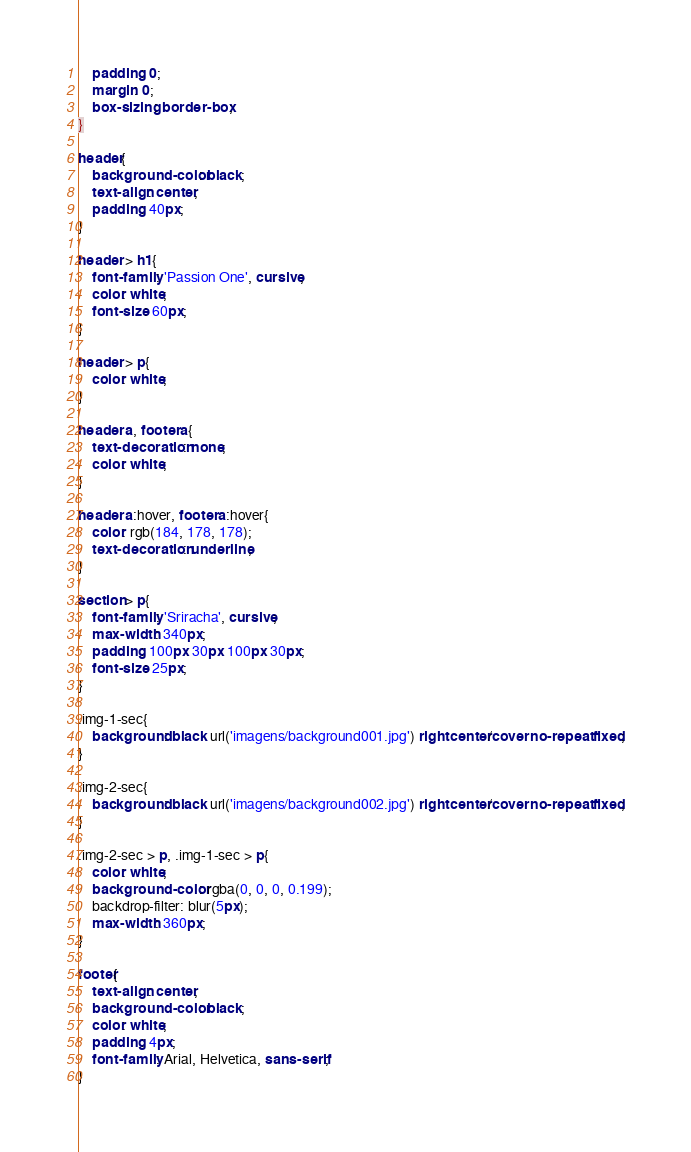Convert code to text. <code><loc_0><loc_0><loc_500><loc_500><_CSS_>    padding: 0;
    margin: 0;
    box-sizing: border-box;
}

header{
    background-color: black;
    text-align: center;
    padding: 40px;
}

header > h1{
    font-family: 'Passion One', cursive;
    color: white;
    font-size: 60px;
}

header > p{
    color: white;
}

header a, footer a{
    text-decoration: none;
    color: white;
}

header a:hover, footer a:hover{
    color: rgb(184, 178, 178);
    text-decoration: underline;
}

section > p{
    font-family: 'Sriracha', cursive;
    max-width: 340px;
    padding: 100px 30px 100px 30px;
    font-size: 25px;
}

.img-1-sec{
    background: black url('imagens/background001.jpg') right center/cover no-repeat fixed;
}

.img-2-sec{
    background: black url('imagens/background002.jpg') right center/cover no-repeat fixed;
}

.img-2-sec > p, .img-1-sec > p{
    color: white;
    background-color: rgba(0, 0, 0, 0.199);
    backdrop-filter: blur(5px);
    max-width: 360px;
}

footer{
    text-align: center;
    background-color: black;
    color: white;
    padding: 4px;
    font-family: Arial, Helvetica, sans-serif;
}
</code> 